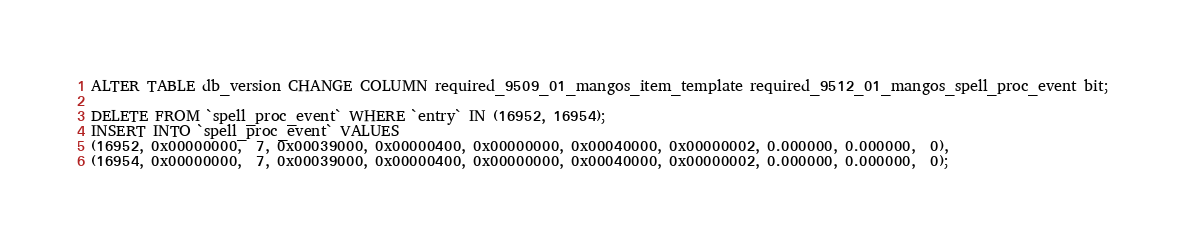<code> <loc_0><loc_0><loc_500><loc_500><_SQL_>ALTER TABLE db_version CHANGE COLUMN required_9509_01_mangos_item_template required_9512_01_mangos_spell_proc_event bit;

DELETE FROM `spell_proc_event` WHERE `entry` IN (16952, 16954);
INSERT INTO `spell_proc_event` VALUES 
(16952, 0x00000000,  7, 0x00039000, 0x00000400, 0x00000000, 0x00040000, 0x00000002, 0.000000, 0.000000,  0),
(16954, 0x00000000,  7, 0x00039000, 0x00000400, 0x00000000, 0x00040000, 0x00000002, 0.000000, 0.000000,  0);</code> 